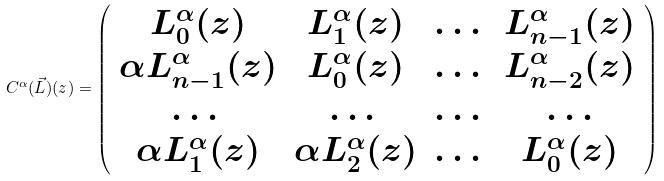<formula> <loc_0><loc_0><loc_500><loc_500>C ^ { \alpha } ( \vec { L } ) ( z ) = \left ( \begin{array} { c c c c } L _ { 0 } ^ { \alpha } ( z ) & L _ { 1 } ^ { \alpha } ( z ) & \dots & L _ { n - 1 } ^ { \alpha } ( z ) \\ \alpha L _ { n - 1 } ^ { \alpha } ( z ) & L _ { 0 } ^ { \alpha } ( z ) & \dots & L _ { n - 2 } ^ { \alpha } ( z ) \\ \dots & \dots & \dots & \dots \\ \alpha L _ { 1 } ^ { \alpha } ( z ) & \alpha L _ { 2 } ^ { \alpha } ( z ) & \dots & L _ { 0 } ^ { \alpha } ( z ) \end{array} \right )</formula> 